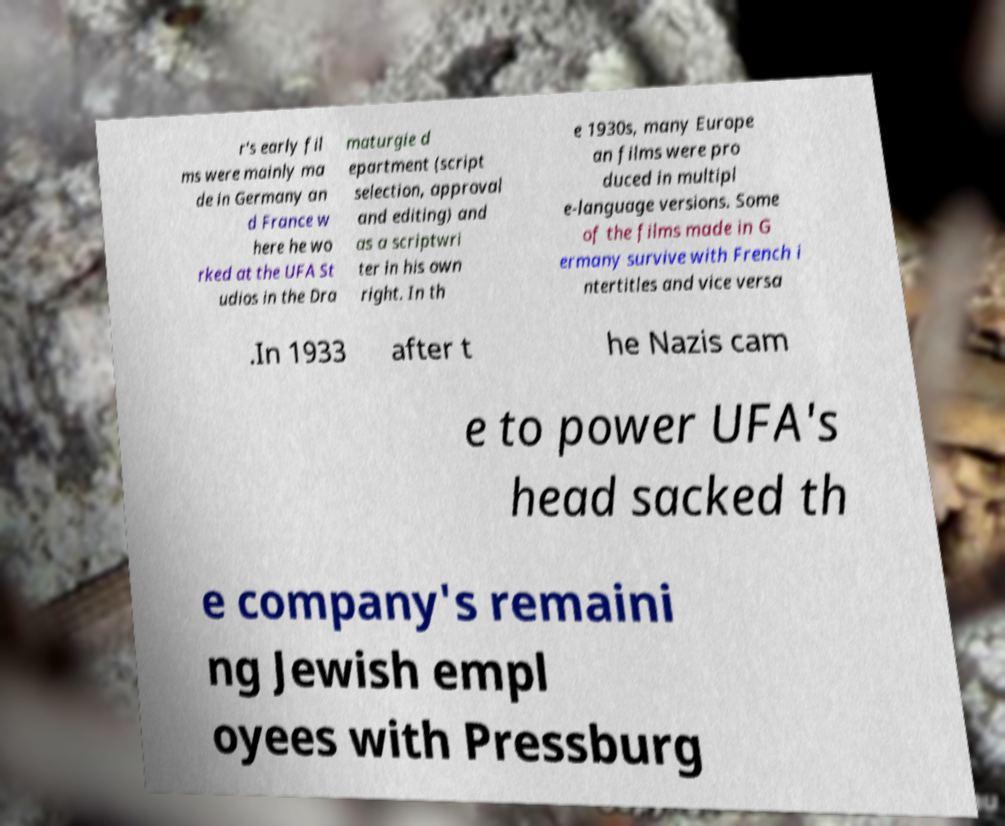What messages or text are displayed in this image? I need them in a readable, typed format. r's early fil ms were mainly ma de in Germany an d France w here he wo rked at the UFA St udios in the Dra maturgie d epartment (script selection, approval and editing) and as a scriptwri ter in his own right. In th e 1930s, many Europe an films were pro duced in multipl e-language versions. Some of the films made in G ermany survive with French i ntertitles and vice versa .In 1933 after t he Nazis cam e to power UFA's head sacked th e company's remaini ng Jewish empl oyees with Pressburg 